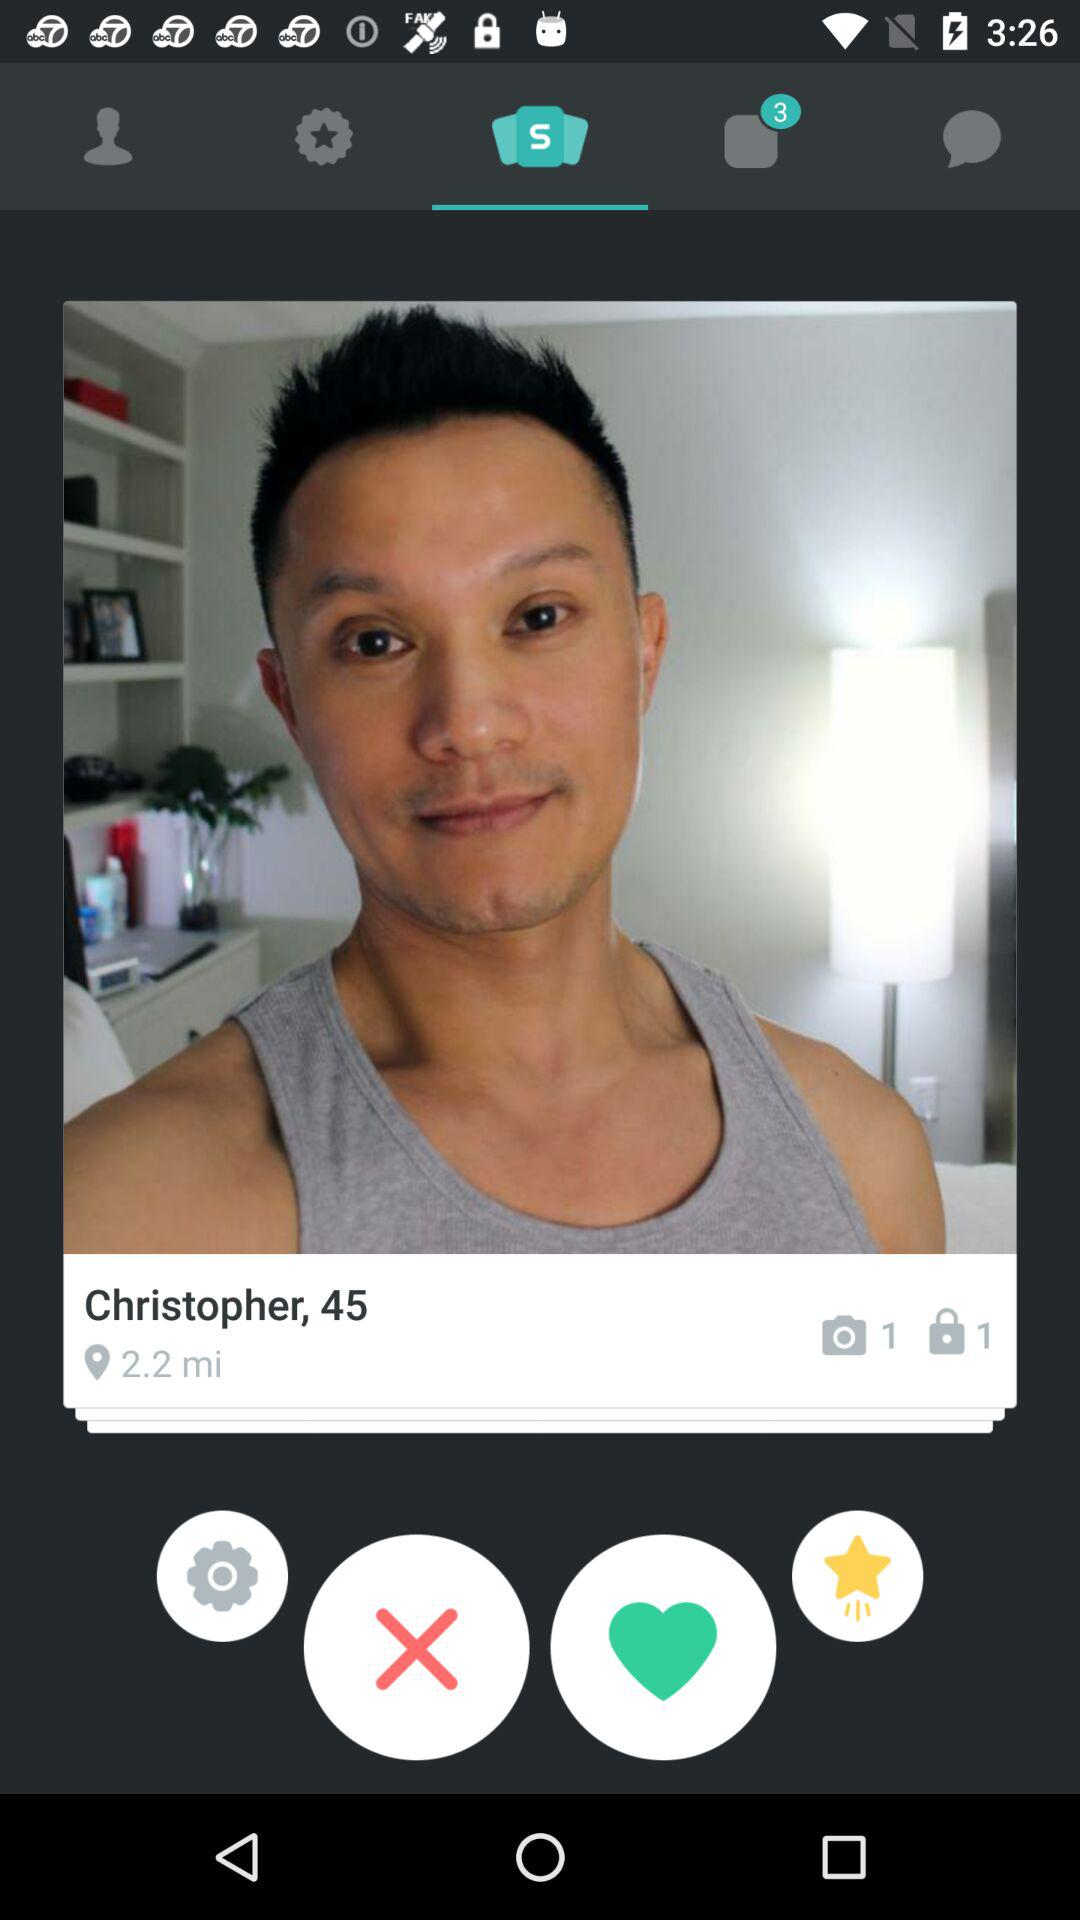What is the age? The age is 45. 